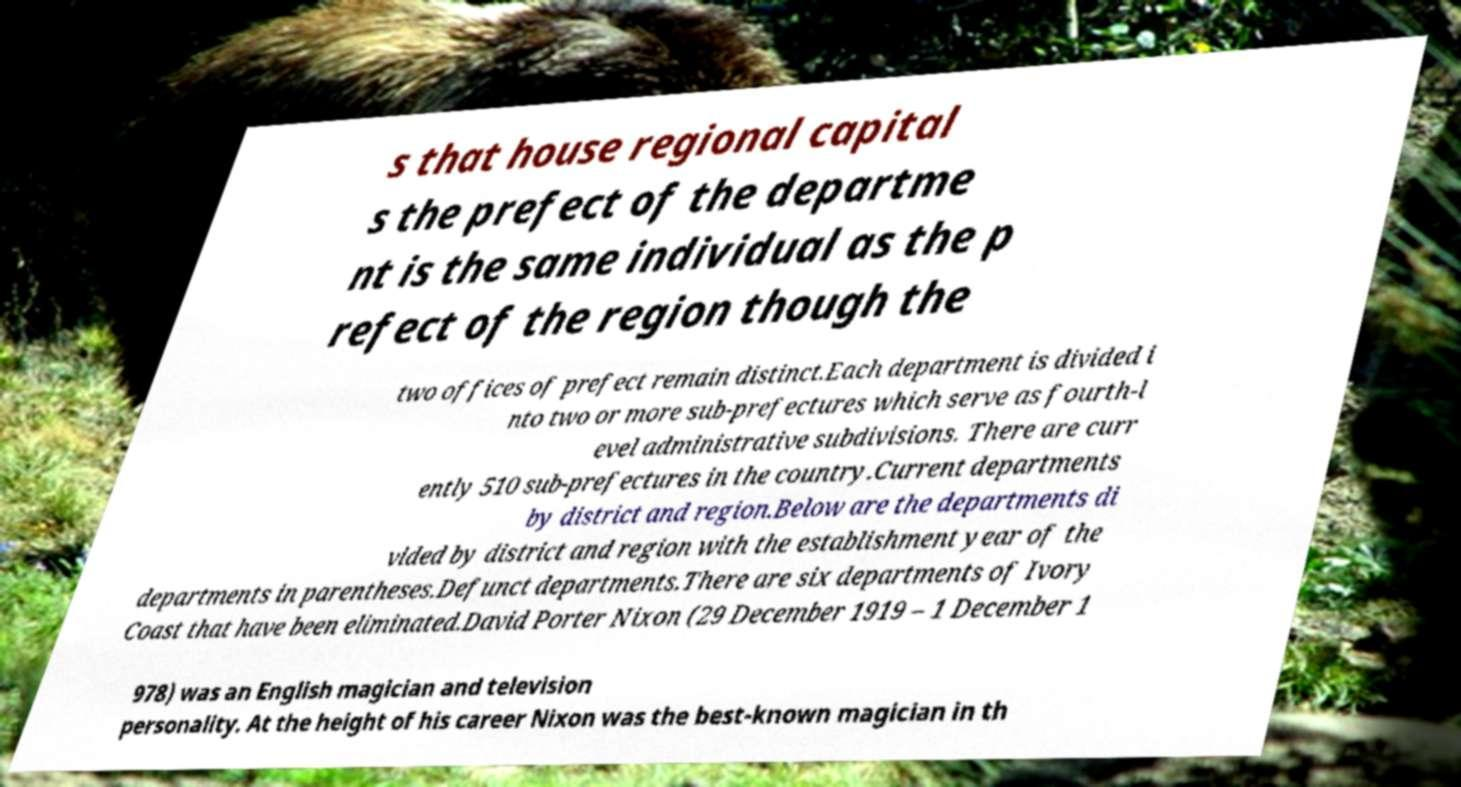Please read and relay the text visible in this image. What does it say? s that house regional capital s the prefect of the departme nt is the same individual as the p refect of the region though the two offices of prefect remain distinct.Each department is divided i nto two or more sub-prefectures which serve as fourth-l evel administrative subdivisions. There are curr ently 510 sub-prefectures in the country.Current departments by district and region.Below are the departments di vided by district and region with the establishment year of the departments in parentheses.Defunct departments.There are six departments of Ivory Coast that have been eliminated.David Porter Nixon (29 December 1919 – 1 December 1 978) was an English magician and television personality. At the height of his career Nixon was the best-known magician in th 